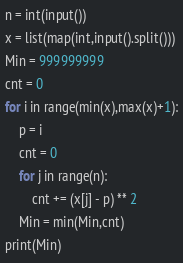Convert code to text. <code><loc_0><loc_0><loc_500><loc_500><_Python_>n = int(input())
x = list(map(int,input().split()))
Min = 999999999
cnt = 0
for i in range(min(x),max(x)+1):
    p = i
    cnt = 0
    for j in range(n):
        cnt += (x[j] - p) ** 2
    Min = min(Min,cnt)
print(Min)</code> 